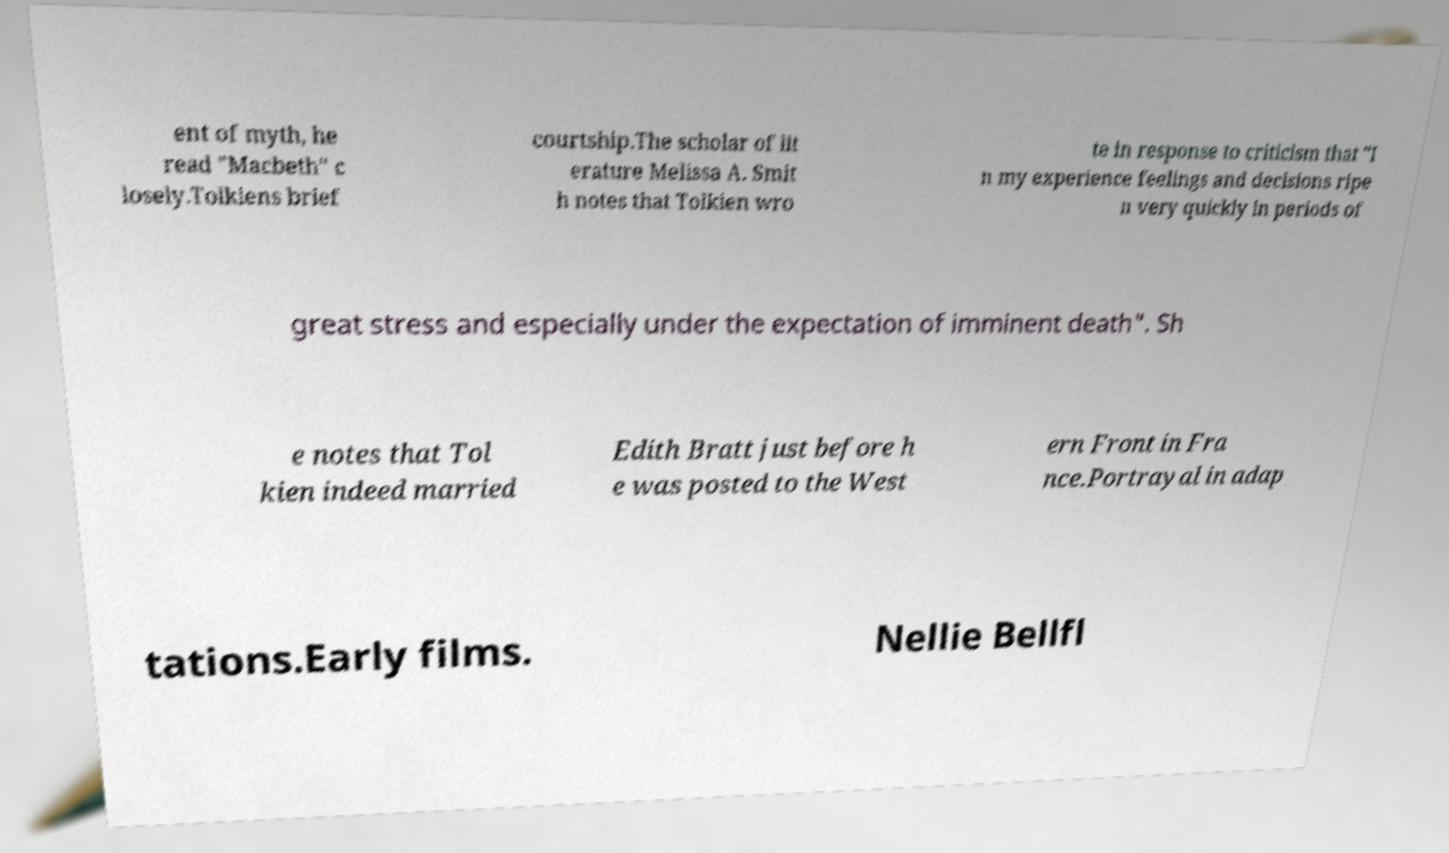Could you extract and type out the text from this image? ent of myth, he read "Macbeth" c losely.Tolkiens brief courtship.The scholar of lit erature Melissa A. Smit h notes that Tolkien wro te in response to criticism that "I n my experience feelings and decisions ripe n very quickly in periods of great stress and especially under the expectation of imminent death". Sh e notes that Tol kien indeed married Edith Bratt just before h e was posted to the West ern Front in Fra nce.Portrayal in adap tations.Early films. Nellie Bellfl 